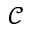Convert formula to latex. <formula><loc_0><loc_0><loc_500><loc_500>\mathcal { C }</formula> 